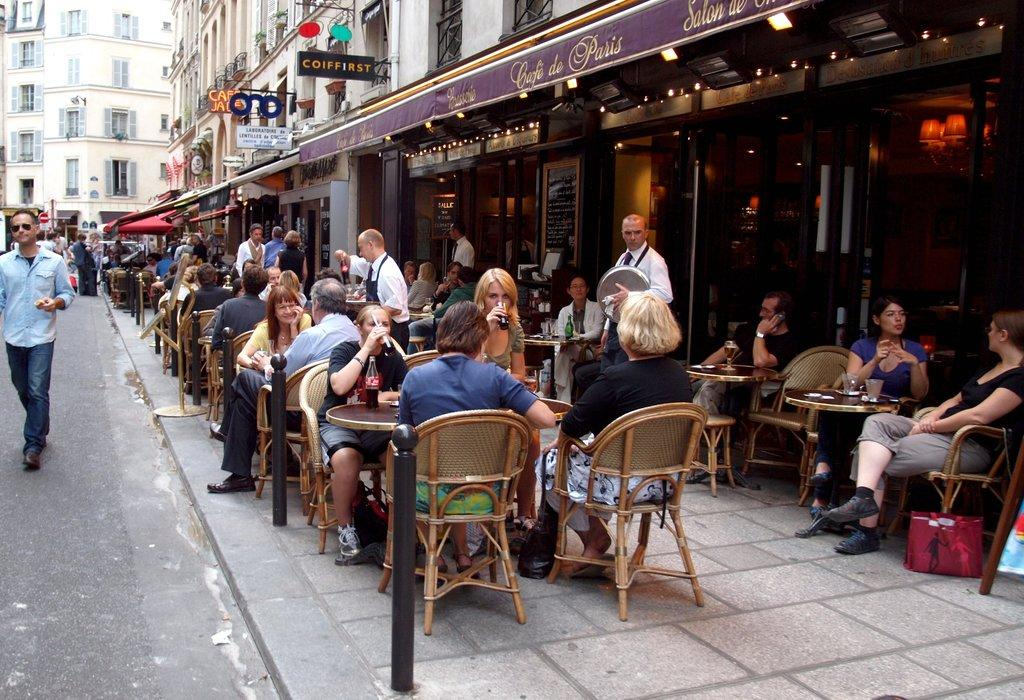What type of structures can be seen in the image? There are buildings in the image. What type of furniture is visible in the image? There are chairs and tables. Are there any individuals present in the image? Yes, there are people present in the image. What type of pie is being served on the table in the image? There is no pie present in the image. How many people are shaking hands in the image? There is no indication of anyone shaking hands in the image. 